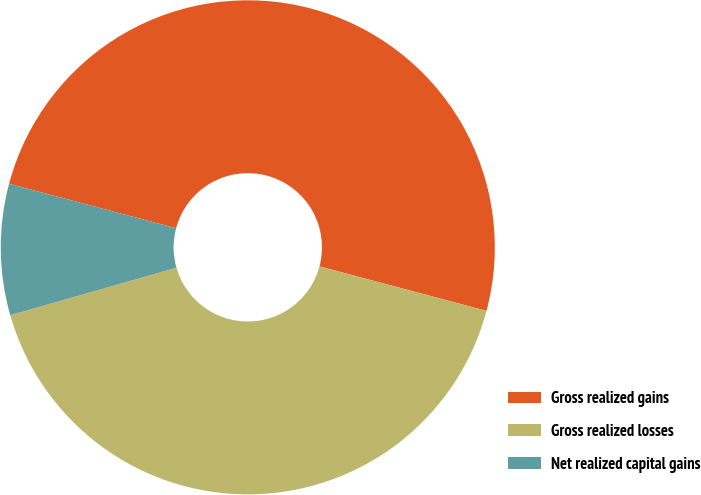<chart> <loc_0><loc_0><loc_500><loc_500><pie_chart><fcel>Gross realized gains<fcel>Gross realized losses<fcel>Net realized capital gains<nl><fcel>50.0%<fcel>41.43%<fcel>8.57%<nl></chart> 